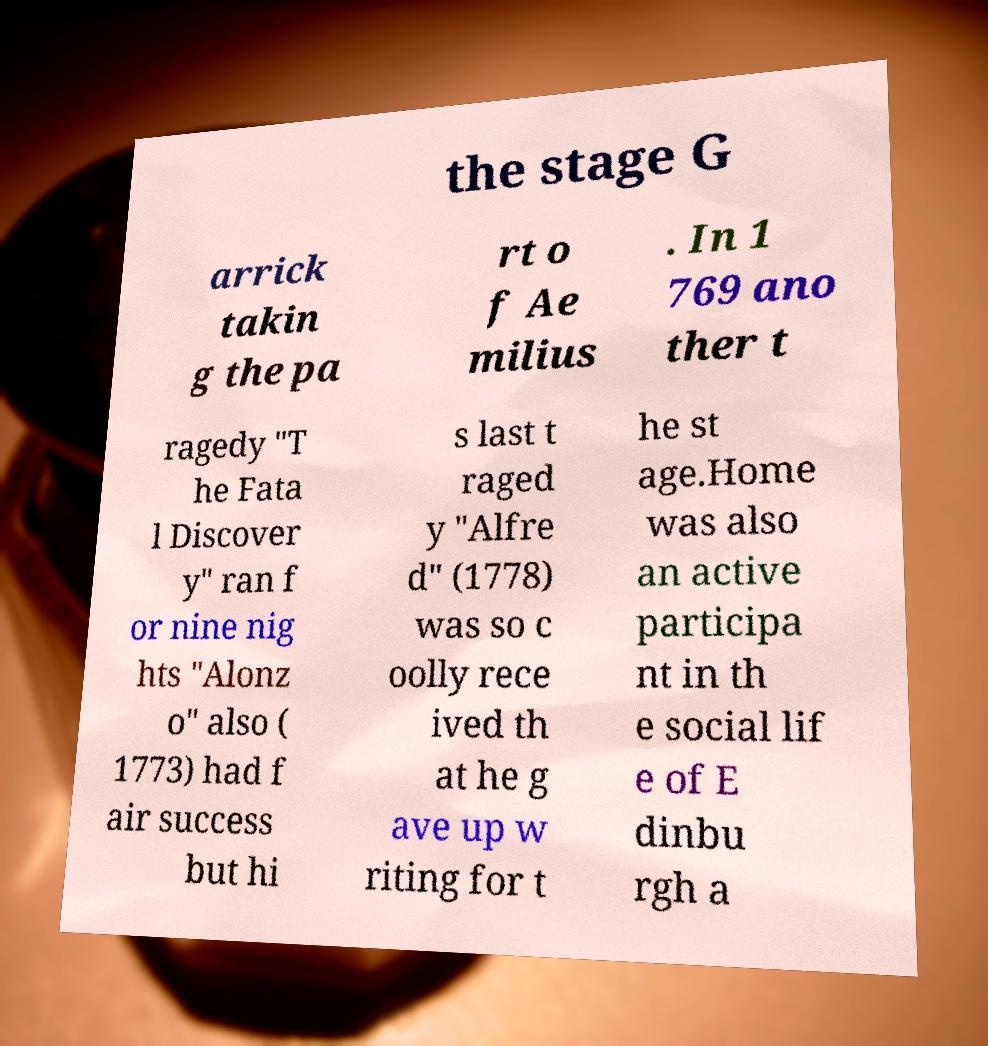Could you assist in decoding the text presented in this image and type it out clearly? the stage G arrick takin g the pa rt o f Ae milius . In 1 769 ano ther t ragedy "T he Fata l Discover y" ran f or nine nig hts "Alonz o" also ( 1773) had f air success but hi s last t raged y "Alfre d" (1778) was so c oolly rece ived th at he g ave up w riting for t he st age.Home was also an active participa nt in th e social lif e of E dinbu rgh a 